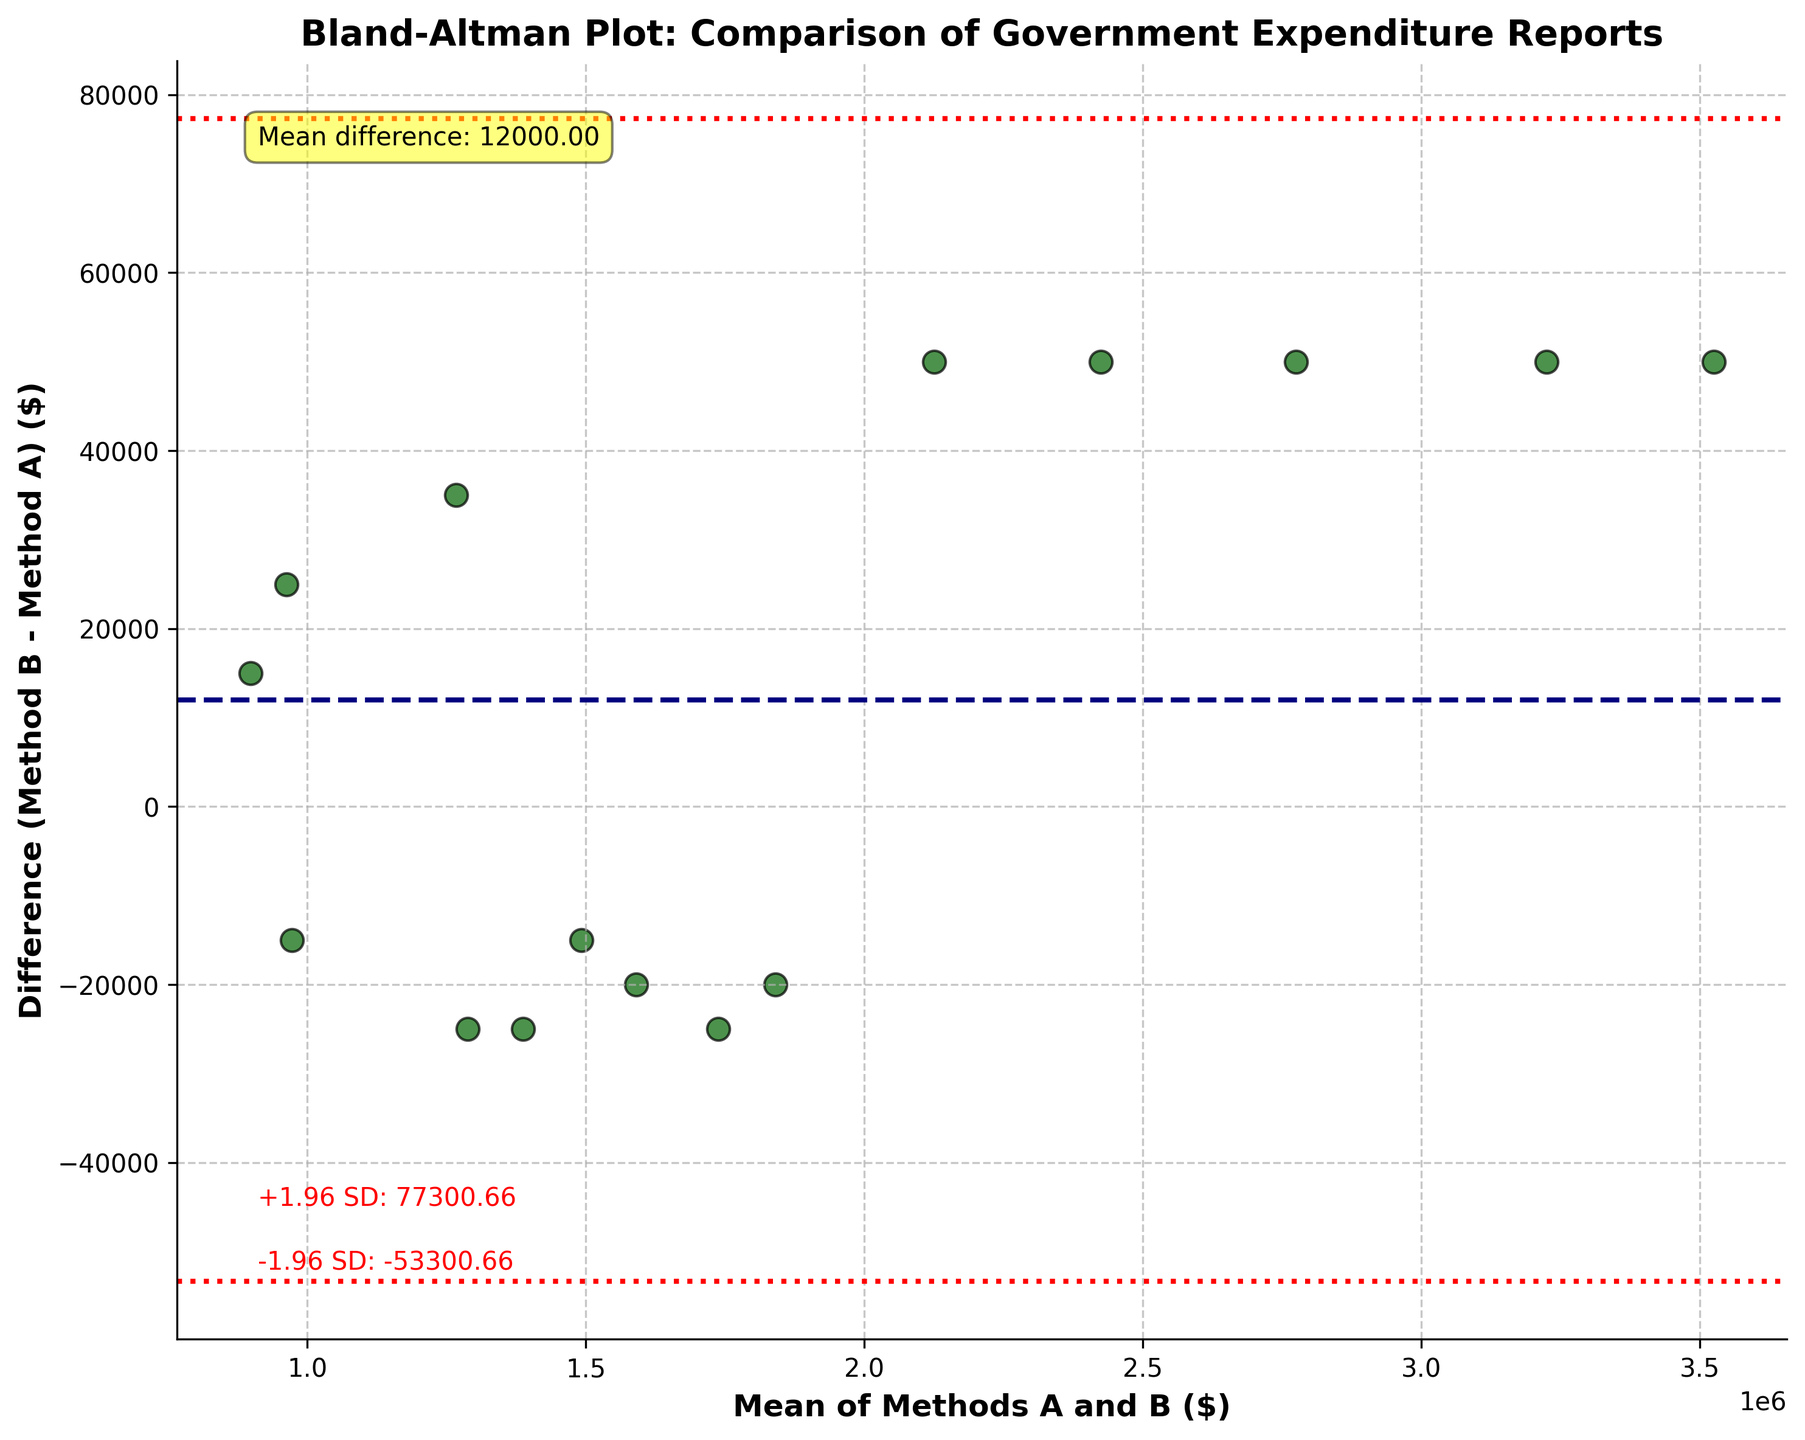what is the title of the figure? The title of the figure is located at the top of the plot and is written in bold, larger font. The title is: "Bland-Altman Plot: Comparison of Government Expenditure Reports"
Answer: Bland-Altman Plot: Comparison of Government Expenditure Reports How many data points are there in the plot? The number of data points can be determined by counting the individual scatter points on the plot. In this case, there are 15 data points on the plot.
Answer: 15 What is the mean difference between Method A and Method B? The mean difference is indicated by the horizontal dashed line and annotated on the plot. It is shown in the yellow textbox as "Mean difference: 20,666.67."
Answer: 20,666.67 What do the red dotted lines represent? The red dotted lines represent the limits of agreement, which are ±1.96 standard deviations (SD) from the mean difference. These limits are crucial in assessing the agreement between the two methods.
Answer: Limits of agreement What is the value of the upper 1.96 SD limit? The upper 1.96 SD limit is indicated by the red dotted line and annotated on the plot. It is shown on the plot as "+1.96 SD: 171,961.04".
Answer: 171,961.04 What is the value of the lower 1.96 SD limit? The lower 1.96 SD limit is indicated by the red dotted line and is annotated on the plot. It is shown on the plot as "-1.96 SD: -130,627.71."
Answer: -130,627.71 What is the range of the limits of agreement? The range of the limits of agreement is the difference between the upper 1.96 SD limit and the lower 1.96 SD limit. It can be calculated as 171,961.04 - (-130,627.71) = 302,588.75.
Answer: 302,588.75 Is the variability in some of the differences (Method B - Method A) large when compared to the mean difference? Yes, the variability is large. This can be seen because the scatter points are spread out widely along the y-axis and spread beyond the mean difference, indicating high variability in the differences.
Answer: Yes Are there any points outside the limits of agreement? To determine if points fall outside the limits of agreement, one must check if any scatter points are placed higher than the +1.96 SD line or lower than the -1.96 SD line. In this plot, there are no points outside the limits of agreement.
Answer: No Which expenditure report method generally reports higher values based on the plot? One needs to assess whether most points fall above or below zero on the difference axis. Since the differences are Method B - Method A, points above zero suggest Method B reports higher values. Most points fall above the mean difference line but within limits, suggesting Method B often reports higher values.
Answer: Method B 